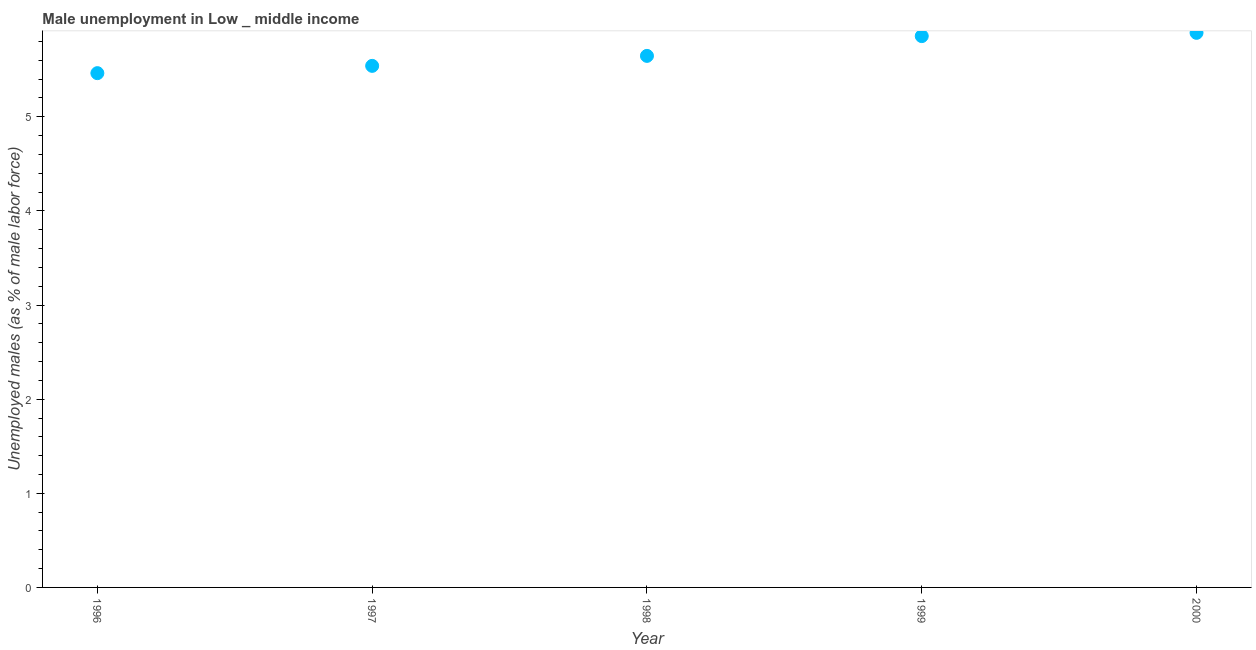What is the unemployed males population in 1998?
Provide a succinct answer. 5.65. Across all years, what is the maximum unemployed males population?
Offer a very short reply. 5.89. Across all years, what is the minimum unemployed males population?
Keep it short and to the point. 5.46. What is the sum of the unemployed males population?
Offer a terse response. 28.4. What is the difference between the unemployed males population in 1997 and 1999?
Your answer should be very brief. -0.32. What is the average unemployed males population per year?
Make the answer very short. 5.68. What is the median unemployed males population?
Provide a short and direct response. 5.65. What is the ratio of the unemployed males population in 1997 to that in 1999?
Provide a succinct answer. 0.95. What is the difference between the highest and the second highest unemployed males population?
Provide a short and direct response. 0.03. Is the sum of the unemployed males population in 1998 and 2000 greater than the maximum unemployed males population across all years?
Your response must be concise. Yes. What is the difference between the highest and the lowest unemployed males population?
Ensure brevity in your answer.  0.43. In how many years, is the unemployed males population greater than the average unemployed males population taken over all years?
Provide a succinct answer. 2. How many dotlines are there?
Give a very brief answer. 1. What is the difference between two consecutive major ticks on the Y-axis?
Offer a terse response. 1. Are the values on the major ticks of Y-axis written in scientific E-notation?
Your answer should be very brief. No. Does the graph contain grids?
Provide a succinct answer. No. What is the title of the graph?
Make the answer very short. Male unemployment in Low _ middle income. What is the label or title of the Y-axis?
Offer a very short reply. Unemployed males (as % of male labor force). What is the Unemployed males (as % of male labor force) in 1996?
Provide a succinct answer. 5.46. What is the Unemployed males (as % of male labor force) in 1997?
Your response must be concise. 5.54. What is the Unemployed males (as % of male labor force) in 1998?
Your answer should be very brief. 5.65. What is the Unemployed males (as % of male labor force) in 1999?
Give a very brief answer. 5.86. What is the Unemployed males (as % of male labor force) in 2000?
Provide a short and direct response. 5.89. What is the difference between the Unemployed males (as % of male labor force) in 1996 and 1997?
Your response must be concise. -0.08. What is the difference between the Unemployed males (as % of male labor force) in 1996 and 1998?
Provide a short and direct response. -0.18. What is the difference between the Unemployed males (as % of male labor force) in 1996 and 1999?
Your answer should be compact. -0.39. What is the difference between the Unemployed males (as % of male labor force) in 1996 and 2000?
Offer a very short reply. -0.43. What is the difference between the Unemployed males (as % of male labor force) in 1997 and 1998?
Provide a succinct answer. -0.11. What is the difference between the Unemployed males (as % of male labor force) in 1997 and 1999?
Make the answer very short. -0.32. What is the difference between the Unemployed males (as % of male labor force) in 1997 and 2000?
Offer a very short reply. -0.35. What is the difference between the Unemployed males (as % of male labor force) in 1998 and 1999?
Keep it short and to the point. -0.21. What is the difference between the Unemployed males (as % of male labor force) in 1998 and 2000?
Provide a succinct answer. -0.24. What is the difference between the Unemployed males (as % of male labor force) in 1999 and 2000?
Give a very brief answer. -0.03. What is the ratio of the Unemployed males (as % of male labor force) in 1996 to that in 1998?
Provide a short and direct response. 0.97. What is the ratio of the Unemployed males (as % of male labor force) in 1996 to that in 1999?
Make the answer very short. 0.93. What is the ratio of the Unemployed males (as % of male labor force) in 1996 to that in 2000?
Your response must be concise. 0.93. What is the ratio of the Unemployed males (as % of male labor force) in 1997 to that in 1998?
Offer a terse response. 0.98. What is the ratio of the Unemployed males (as % of male labor force) in 1997 to that in 1999?
Your answer should be very brief. 0.95. What is the ratio of the Unemployed males (as % of male labor force) in 1998 to that in 2000?
Provide a succinct answer. 0.96. 